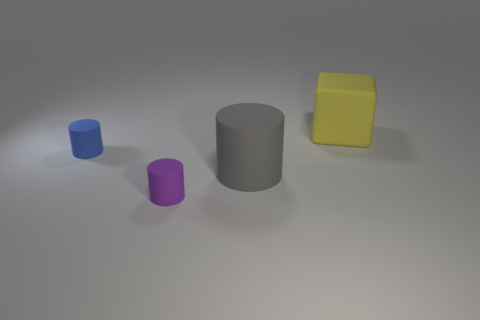Which of the objects in the image appears to have the smoothest surface? The large gray cylinder appears to have the smoothest surface, reflecting light evenly and showing no visible texture. 